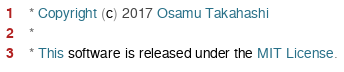<code> <loc_0><loc_0><loc_500><loc_500><_Scala_>  * Copyright (c) 2017 Osamu Takahashi
  *
  * This software is released under the MIT License.</code> 